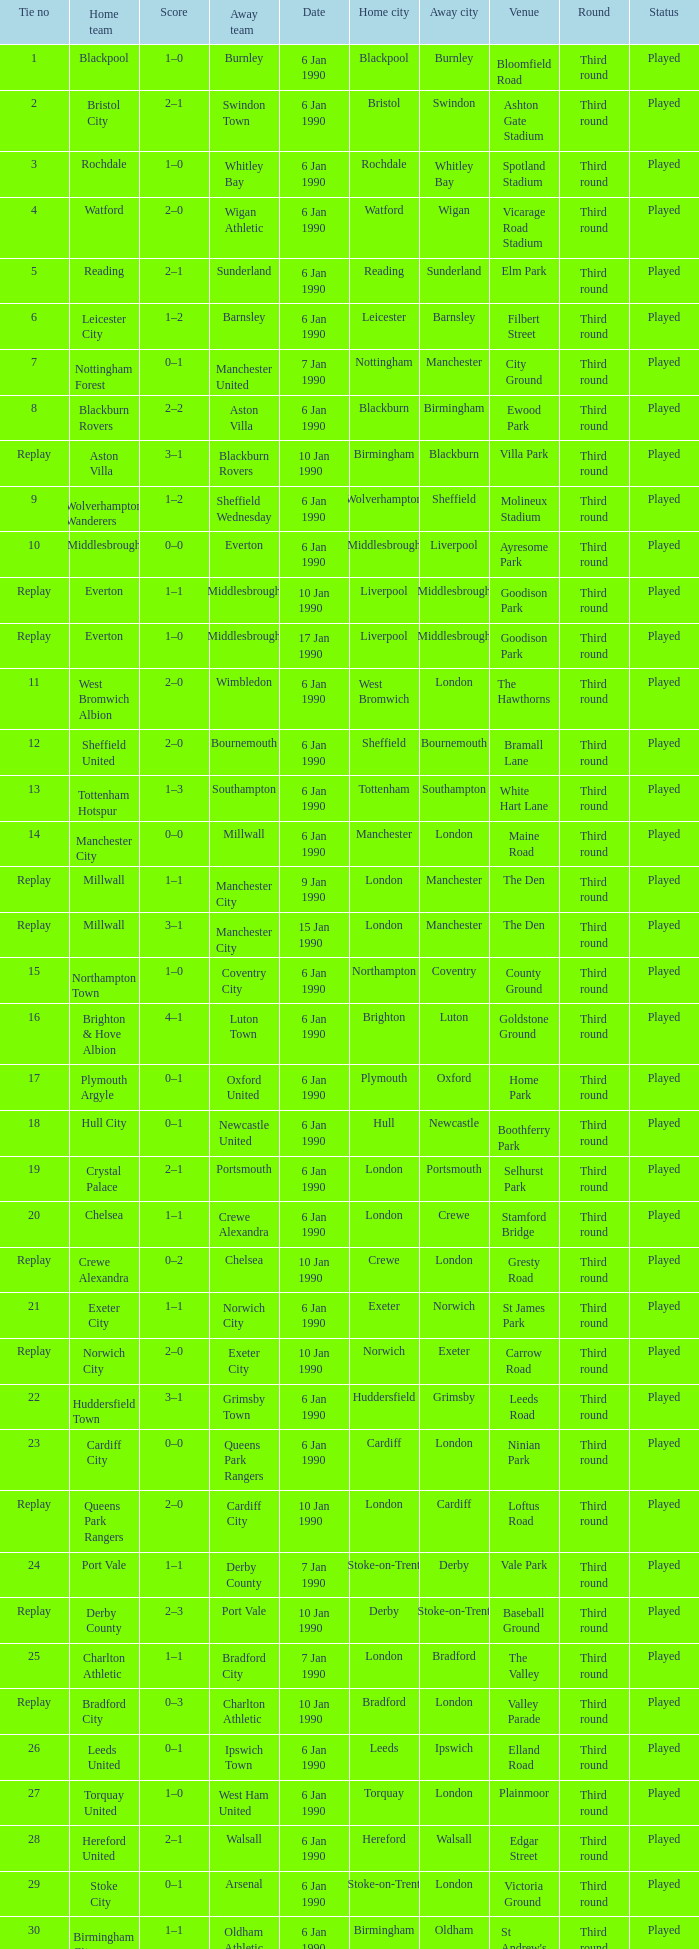What is the score of the game against away team exeter city on 10 jan 1990? 2–0. 